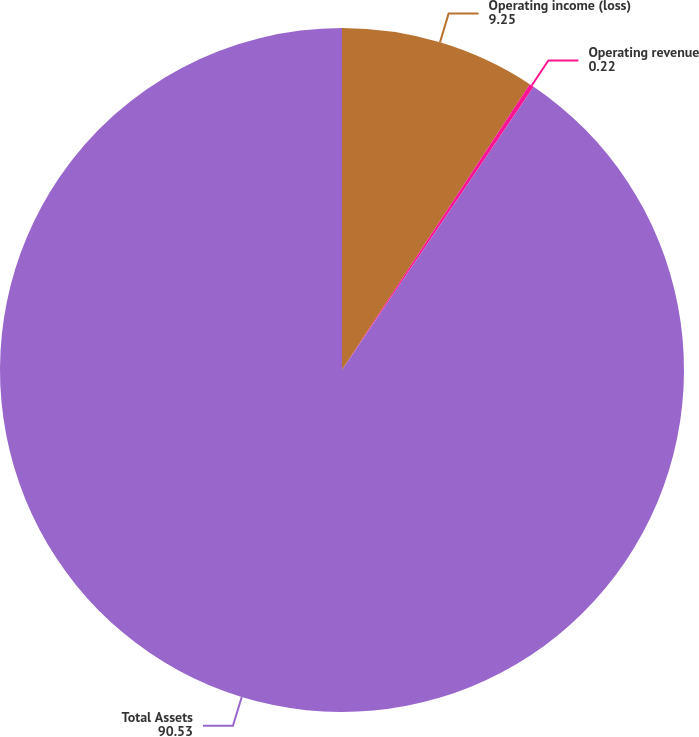Convert chart to OTSL. <chart><loc_0><loc_0><loc_500><loc_500><pie_chart><fcel>Operating income (loss)<fcel>Operating revenue<fcel>Total Assets<nl><fcel>9.25%<fcel>0.22%<fcel>90.53%<nl></chart> 